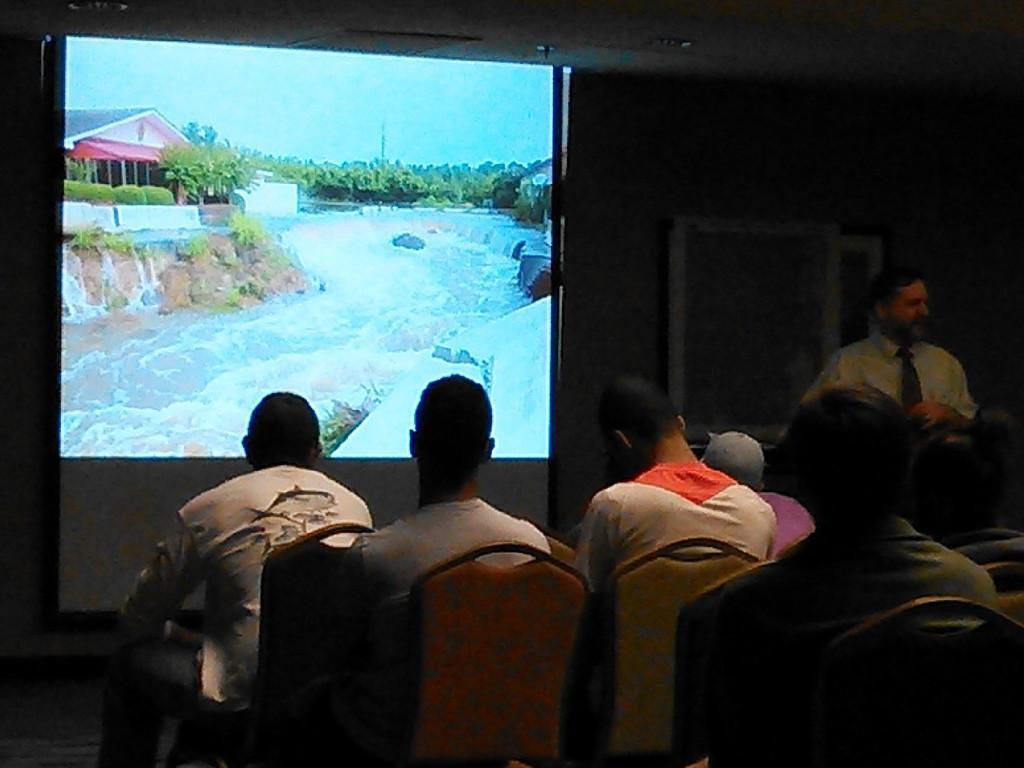In one or two sentences, can you explain what this image depicts? The picture is clicked inside the room. On the right we can see the group of person sitting on the chairs. On the right corner there is a person wearing shirt, tie and standing. In the background we can see the wall, door and a projector screen and we can see the picture consists of water body, trees, plants, house, rocks, sky and some other objects, on the projector screen. At the top there is a roof. 